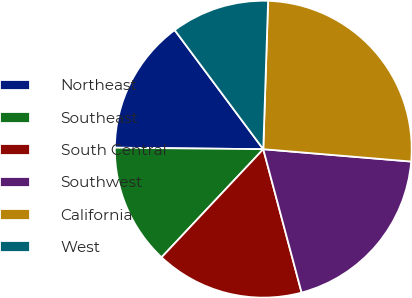Convert chart. <chart><loc_0><loc_0><loc_500><loc_500><pie_chart><fcel>Northeast<fcel>Southeast<fcel>South Central<fcel>Southwest<fcel>California<fcel>West<nl><fcel>14.66%<fcel>13.15%<fcel>16.17%<fcel>19.52%<fcel>25.81%<fcel>10.7%<nl></chart> 